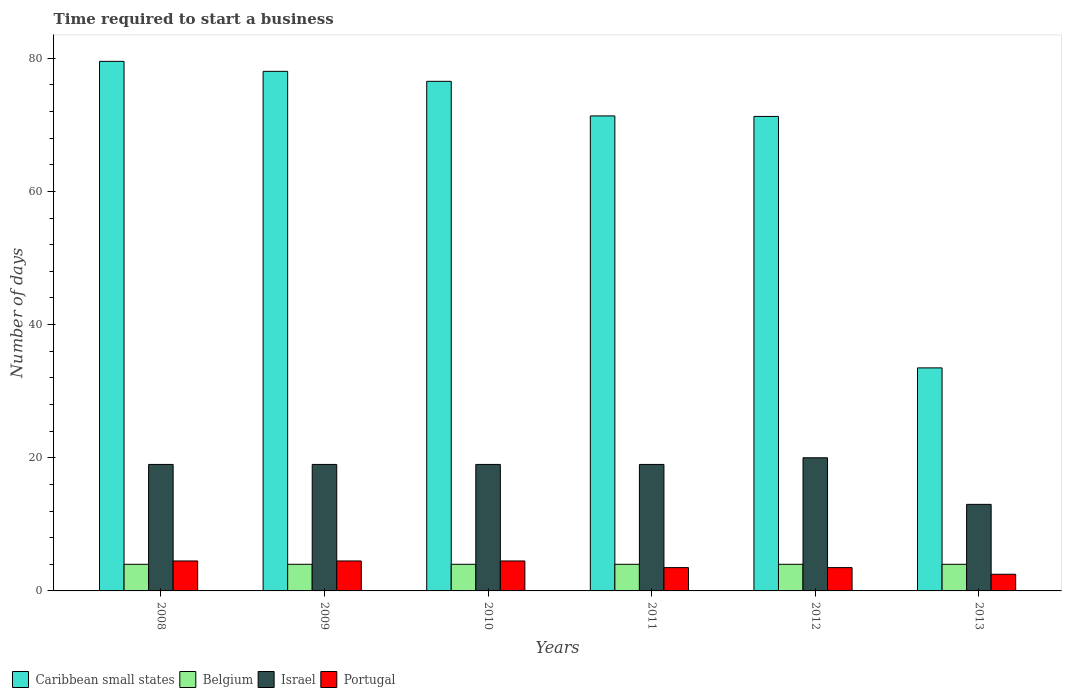How many different coloured bars are there?
Your answer should be very brief. 4. How many groups of bars are there?
Your answer should be very brief. 6. Are the number of bars per tick equal to the number of legend labels?
Your response must be concise. Yes. Are the number of bars on each tick of the X-axis equal?
Provide a succinct answer. Yes. How many bars are there on the 1st tick from the right?
Offer a very short reply. 4. What is the label of the 2nd group of bars from the left?
Your answer should be compact. 2009. Across all years, what is the maximum number of days required to start a business in Israel?
Your answer should be very brief. 20. Across all years, what is the minimum number of days required to start a business in Portugal?
Your response must be concise. 2.5. In which year was the number of days required to start a business in Portugal minimum?
Provide a succinct answer. 2013. What is the total number of days required to start a business in Caribbean small states in the graph?
Offer a terse response. 410.24. What is the difference between the number of days required to start a business in Belgium in 2009 and that in 2011?
Offer a terse response. 0. What is the difference between the number of days required to start a business in Caribbean small states in 2008 and the number of days required to start a business in Portugal in 2010?
Your answer should be very brief. 75.04. What is the average number of days required to start a business in Israel per year?
Your answer should be very brief. 18.17. What is the ratio of the number of days required to start a business in Caribbean small states in 2010 to that in 2013?
Give a very brief answer. 2.28. Is the number of days required to start a business in Israel in 2010 less than that in 2013?
Offer a very short reply. No. What is the difference between the highest and the lowest number of days required to start a business in Belgium?
Provide a short and direct response. 0. Is it the case that in every year, the sum of the number of days required to start a business in Israel and number of days required to start a business in Belgium is greater than the sum of number of days required to start a business in Portugal and number of days required to start a business in Caribbean small states?
Provide a short and direct response. Yes. What does the 1st bar from the left in 2008 represents?
Ensure brevity in your answer.  Caribbean small states. How many bars are there?
Your answer should be compact. 24. Are all the bars in the graph horizontal?
Ensure brevity in your answer.  No. How many years are there in the graph?
Your answer should be very brief. 6. What is the difference between two consecutive major ticks on the Y-axis?
Keep it short and to the point. 20. How are the legend labels stacked?
Your answer should be very brief. Horizontal. What is the title of the graph?
Offer a terse response. Time required to start a business. Does "Sweden" appear as one of the legend labels in the graph?
Your answer should be compact. No. What is the label or title of the Y-axis?
Provide a succinct answer. Number of days. What is the Number of days of Caribbean small states in 2008?
Keep it short and to the point. 79.54. What is the Number of days of Portugal in 2008?
Your answer should be compact. 4.5. What is the Number of days of Caribbean small states in 2009?
Your response must be concise. 78.04. What is the Number of days of Belgium in 2009?
Your response must be concise. 4. What is the Number of days of Caribbean small states in 2010?
Offer a terse response. 76.54. What is the Number of days in Israel in 2010?
Offer a very short reply. 19. What is the Number of days of Caribbean small states in 2011?
Give a very brief answer. 71.35. What is the Number of days of Belgium in 2011?
Make the answer very short. 4. What is the Number of days in Israel in 2011?
Your answer should be very brief. 19. What is the Number of days in Caribbean small states in 2012?
Offer a very short reply. 71.27. What is the Number of days in Portugal in 2012?
Keep it short and to the point. 3.5. What is the Number of days of Caribbean small states in 2013?
Offer a terse response. 33.5. What is the Number of days in Israel in 2013?
Your answer should be compact. 13. Across all years, what is the maximum Number of days in Caribbean small states?
Provide a short and direct response. 79.54. Across all years, what is the maximum Number of days of Portugal?
Offer a very short reply. 4.5. Across all years, what is the minimum Number of days in Caribbean small states?
Offer a very short reply. 33.5. Across all years, what is the minimum Number of days in Portugal?
Provide a succinct answer. 2.5. What is the total Number of days of Caribbean small states in the graph?
Your response must be concise. 410.24. What is the total Number of days of Belgium in the graph?
Your answer should be compact. 24. What is the total Number of days in Israel in the graph?
Offer a very short reply. 109. What is the difference between the Number of days in Caribbean small states in 2008 and that in 2009?
Provide a short and direct response. 1.5. What is the difference between the Number of days of Caribbean small states in 2008 and that in 2010?
Ensure brevity in your answer.  3. What is the difference between the Number of days of Belgium in 2008 and that in 2010?
Ensure brevity in your answer.  0. What is the difference between the Number of days of Portugal in 2008 and that in 2010?
Your response must be concise. 0. What is the difference between the Number of days of Caribbean small states in 2008 and that in 2011?
Your answer should be compact. 8.2. What is the difference between the Number of days of Belgium in 2008 and that in 2011?
Your answer should be very brief. 0. What is the difference between the Number of days of Caribbean small states in 2008 and that in 2012?
Ensure brevity in your answer.  8.27. What is the difference between the Number of days in Belgium in 2008 and that in 2012?
Ensure brevity in your answer.  0. What is the difference between the Number of days of Portugal in 2008 and that in 2012?
Your answer should be compact. 1. What is the difference between the Number of days of Caribbean small states in 2008 and that in 2013?
Your response must be concise. 46.04. What is the difference between the Number of days in Israel in 2008 and that in 2013?
Ensure brevity in your answer.  6. What is the difference between the Number of days of Belgium in 2009 and that in 2010?
Provide a succinct answer. 0. What is the difference between the Number of days in Israel in 2009 and that in 2010?
Offer a terse response. 0. What is the difference between the Number of days in Portugal in 2009 and that in 2010?
Offer a terse response. 0. What is the difference between the Number of days of Caribbean small states in 2009 and that in 2011?
Your answer should be compact. 6.7. What is the difference between the Number of days in Belgium in 2009 and that in 2011?
Provide a short and direct response. 0. What is the difference between the Number of days of Portugal in 2009 and that in 2011?
Your response must be concise. 1. What is the difference between the Number of days of Caribbean small states in 2009 and that in 2012?
Offer a very short reply. 6.77. What is the difference between the Number of days of Portugal in 2009 and that in 2012?
Offer a very short reply. 1. What is the difference between the Number of days in Caribbean small states in 2009 and that in 2013?
Make the answer very short. 44.54. What is the difference between the Number of days in Israel in 2009 and that in 2013?
Ensure brevity in your answer.  6. What is the difference between the Number of days of Caribbean small states in 2010 and that in 2011?
Your answer should be very brief. 5.2. What is the difference between the Number of days of Caribbean small states in 2010 and that in 2012?
Provide a short and direct response. 5.27. What is the difference between the Number of days of Belgium in 2010 and that in 2012?
Ensure brevity in your answer.  0. What is the difference between the Number of days of Israel in 2010 and that in 2012?
Give a very brief answer. -1. What is the difference between the Number of days of Caribbean small states in 2010 and that in 2013?
Provide a short and direct response. 43.04. What is the difference between the Number of days of Portugal in 2010 and that in 2013?
Offer a terse response. 2. What is the difference between the Number of days of Caribbean small states in 2011 and that in 2012?
Your answer should be compact. 0.08. What is the difference between the Number of days in Belgium in 2011 and that in 2012?
Make the answer very short. 0. What is the difference between the Number of days of Israel in 2011 and that in 2012?
Your answer should be very brief. -1. What is the difference between the Number of days in Caribbean small states in 2011 and that in 2013?
Make the answer very short. 37.85. What is the difference between the Number of days in Belgium in 2011 and that in 2013?
Give a very brief answer. 0. What is the difference between the Number of days in Caribbean small states in 2012 and that in 2013?
Ensure brevity in your answer.  37.77. What is the difference between the Number of days of Belgium in 2012 and that in 2013?
Your answer should be compact. 0. What is the difference between the Number of days in Portugal in 2012 and that in 2013?
Your answer should be very brief. 1. What is the difference between the Number of days in Caribbean small states in 2008 and the Number of days in Belgium in 2009?
Offer a terse response. 75.54. What is the difference between the Number of days of Caribbean small states in 2008 and the Number of days of Israel in 2009?
Your answer should be compact. 60.54. What is the difference between the Number of days in Caribbean small states in 2008 and the Number of days in Portugal in 2009?
Your answer should be very brief. 75.04. What is the difference between the Number of days in Belgium in 2008 and the Number of days in Israel in 2009?
Provide a succinct answer. -15. What is the difference between the Number of days in Belgium in 2008 and the Number of days in Portugal in 2009?
Offer a very short reply. -0.5. What is the difference between the Number of days in Caribbean small states in 2008 and the Number of days in Belgium in 2010?
Give a very brief answer. 75.54. What is the difference between the Number of days of Caribbean small states in 2008 and the Number of days of Israel in 2010?
Provide a short and direct response. 60.54. What is the difference between the Number of days in Caribbean small states in 2008 and the Number of days in Portugal in 2010?
Your response must be concise. 75.04. What is the difference between the Number of days in Belgium in 2008 and the Number of days in Israel in 2010?
Provide a short and direct response. -15. What is the difference between the Number of days in Belgium in 2008 and the Number of days in Portugal in 2010?
Make the answer very short. -0.5. What is the difference between the Number of days of Caribbean small states in 2008 and the Number of days of Belgium in 2011?
Your answer should be very brief. 75.54. What is the difference between the Number of days of Caribbean small states in 2008 and the Number of days of Israel in 2011?
Your answer should be very brief. 60.54. What is the difference between the Number of days in Caribbean small states in 2008 and the Number of days in Portugal in 2011?
Your response must be concise. 76.04. What is the difference between the Number of days of Belgium in 2008 and the Number of days of Israel in 2011?
Provide a short and direct response. -15. What is the difference between the Number of days of Belgium in 2008 and the Number of days of Portugal in 2011?
Your response must be concise. 0.5. What is the difference between the Number of days of Caribbean small states in 2008 and the Number of days of Belgium in 2012?
Make the answer very short. 75.54. What is the difference between the Number of days of Caribbean small states in 2008 and the Number of days of Israel in 2012?
Your answer should be compact. 59.54. What is the difference between the Number of days in Caribbean small states in 2008 and the Number of days in Portugal in 2012?
Make the answer very short. 76.04. What is the difference between the Number of days in Belgium in 2008 and the Number of days in Israel in 2012?
Your answer should be compact. -16. What is the difference between the Number of days in Caribbean small states in 2008 and the Number of days in Belgium in 2013?
Offer a very short reply. 75.54. What is the difference between the Number of days of Caribbean small states in 2008 and the Number of days of Israel in 2013?
Offer a terse response. 66.54. What is the difference between the Number of days of Caribbean small states in 2008 and the Number of days of Portugal in 2013?
Provide a succinct answer. 77.04. What is the difference between the Number of days in Belgium in 2008 and the Number of days in Portugal in 2013?
Provide a short and direct response. 1.5. What is the difference between the Number of days of Israel in 2008 and the Number of days of Portugal in 2013?
Provide a short and direct response. 16.5. What is the difference between the Number of days in Caribbean small states in 2009 and the Number of days in Belgium in 2010?
Ensure brevity in your answer.  74.04. What is the difference between the Number of days of Caribbean small states in 2009 and the Number of days of Israel in 2010?
Your answer should be very brief. 59.04. What is the difference between the Number of days of Caribbean small states in 2009 and the Number of days of Portugal in 2010?
Ensure brevity in your answer.  73.54. What is the difference between the Number of days in Caribbean small states in 2009 and the Number of days in Belgium in 2011?
Offer a terse response. 74.04. What is the difference between the Number of days of Caribbean small states in 2009 and the Number of days of Israel in 2011?
Give a very brief answer. 59.04. What is the difference between the Number of days in Caribbean small states in 2009 and the Number of days in Portugal in 2011?
Provide a short and direct response. 74.54. What is the difference between the Number of days of Caribbean small states in 2009 and the Number of days of Belgium in 2012?
Offer a very short reply. 74.04. What is the difference between the Number of days in Caribbean small states in 2009 and the Number of days in Israel in 2012?
Your answer should be compact. 58.04. What is the difference between the Number of days in Caribbean small states in 2009 and the Number of days in Portugal in 2012?
Provide a short and direct response. 74.54. What is the difference between the Number of days of Belgium in 2009 and the Number of days of Portugal in 2012?
Offer a very short reply. 0.5. What is the difference between the Number of days in Caribbean small states in 2009 and the Number of days in Belgium in 2013?
Your answer should be compact. 74.04. What is the difference between the Number of days of Caribbean small states in 2009 and the Number of days of Israel in 2013?
Your answer should be compact. 65.04. What is the difference between the Number of days of Caribbean small states in 2009 and the Number of days of Portugal in 2013?
Provide a short and direct response. 75.54. What is the difference between the Number of days of Belgium in 2009 and the Number of days of Israel in 2013?
Your answer should be compact. -9. What is the difference between the Number of days in Caribbean small states in 2010 and the Number of days in Belgium in 2011?
Give a very brief answer. 72.54. What is the difference between the Number of days of Caribbean small states in 2010 and the Number of days of Israel in 2011?
Offer a terse response. 57.54. What is the difference between the Number of days in Caribbean small states in 2010 and the Number of days in Portugal in 2011?
Offer a terse response. 73.04. What is the difference between the Number of days in Belgium in 2010 and the Number of days in Israel in 2011?
Offer a terse response. -15. What is the difference between the Number of days of Caribbean small states in 2010 and the Number of days of Belgium in 2012?
Offer a terse response. 72.54. What is the difference between the Number of days of Caribbean small states in 2010 and the Number of days of Israel in 2012?
Your response must be concise. 56.54. What is the difference between the Number of days of Caribbean small states in 2010 and the Number of days of Portugal in 2012?
Your answer should be very brief. 73.04. What is the difference between the Number of days of Belgium in 2010 and the Number of days of Portugal in 2012?
Keep it short and to the point. 0.5. What is the difference between the Number of days of Caribbean small states in 2010 and the Number of days of Belgium in 2013?
Provide a short and direct response. 72.54. What is the difference between the Number of days in Caribbean small states in 2010 and the Number of days in Israel in 2013?
Ensure brevity in your answer.  63.54. What is the difference between the Number of days of Caribbean small states in 2010 and the Number of days of Portugal in 2013?
Keep it short and to the point. 74.04. What is the difference between the Number of days of Belgium in 2010 and the Number of days of Israel in 2013?
Provide a short and direct response. -9. What is the difference between the Number of days of Caribbean small states in 2011 and the Number of days of Belgium in 2012?
Offer a very short reply. 67.35. What is the difference between the Number of days in Caribbean small states in 2011 and the Number of days in Israel in 2012?
Provide a succinct answer. 51.35. What is the difference between the Number of days in Caribbean small states in 2011 and the Number of days in Portugal in 2012?
Keep it short and to the point. 67.85. What is the difference between the Number of days in Belgium in 2011 and the Number of days in Israel in 2012?
Provide a succinct answer. -16. What is the difference between the Number of days in Israel in 2011 and the Number of days in Portugal in 2012?
Offer a very short reply. 15.5. What is the difference between the Number of days in Caribbean small states in 2011 and the Number of days in Belgium in 2013?
Offer a terse response. 67.35. What is the difference between the Number of days in Caribbean small states in 2011 and the Number of days in Israel in 2013?
Your answer should be compact. 58.35. What is the difference between the Number of days in Caribbean small states in 2011 and the Number of days in Portugal in 2013?
Your response must be concise. 68.85. What is the difference between the Number of days of Belgium in 2011 and the Number of days of Israel in 2013?
Ensure brevity in your answer.  -9. What is the difference between the Number of days of Belgium in 2011 and the Number of days of Portugal in 2013?
Offer a very short reply. 1.5. What is the difference between the Number of days in Israel in 2011 and the Number of days in Portugal in 2013?
Give a very brief answer. 16.5. What is the difference between the Number of days of Caribbean small states in 2012 and the Number of days of Belgium in 2013?
Your answer should be very brief. 67.27. What is the difference between the Number of days of Caribbean small states in 2012 and the Number of days of Israel in 2013?
Provide a short and direct response. 58.27. What is the difference between the Number of days of Caribbean small states in 2012 and the Number of days of Portugal in 2013?
Your answer should be compact. 68.77. What is the difference between the Number of days of Belgium in 2012 and the Number of days of Israel in 2013?
Your response must be concise. -9. What is the average Number of days of Caribbean small states per year?
Your answer should be compact. 68.37. What is the average Number of days in Israel per year?
Make the answer very short. 18.17. What is the average Number of days in Portugal per year?
Your answer should be very brief. 3.83. In the year 2008, what is the difference between the Number of days of Caribbean small states and Number of days of Belgium?
Offer a terse response. 75.54. In the year 2008, what is the difference between the Number of days of Caribbean small states and Number of days of Israel?
Provide a succinct answer. 60.54. In the year 2008, what is the difference between the Number of days in Caribbean small states and Number of days in Portugal?
Provide a short and direct response. 75.04. In the year 2008, what is the difference between the Number of days in Belgium and Number of days in Israel?
Ensure brevity in your answer.  -15. In the year 2008, what is the difference between the Number of days in Belgium and Number of days in Portugal?
Your response must be concise. -0.5. In the year 2009, what is the difference between the Number of days in Caribbean small states and Number of days in Belgium?
Provide a succinct answer. 74.04. In the year 2009, what is the difference between the Number of days in Caribbean small states and Number of days in Israel?
Keep it short and to the point. 59.04. In the year 2009, what is the difference between the Number of days of Caribbean small states and Number of days of Portugal?
Your response must be concise. 73.54. In the year 2009, what is the difference between the Number of days of Belgium and Number of days of Portugal?
Make the answer very short. -0.5. In the year 2010, what is the difference between the Number of days of Caribbean small states and Number of days of Belgium?
Your answer should be very brief. 72.54. In the year 2010, what is the difference between the Number of days in Caribbean small states and Number of days in Israel?
Give a very brief answer. 57.54. In the year 2010, what is the difference between the Number of days in Caribbean small states and Number of days in Portugal?
Give a very brief answer. 72.04. In the year 2010, what is the difference between the Number of days of Israel and Number of days of Portugal?
Your answer should be compact. 14.5. In the year 2011, what is the difference between the Number of days in Caribbean small states and Number of days in Belgium?
Ensure brevity in your answer.  67.35. In the year 2011, what is the difference between the Number of days of Caribbean small states and Number of days of Israel?
Your answer should be compact. 52.35. In the year 2011, what is the difference between the Number of days of Caribbean small states and Number of days of Portugal?
Your response must be concise. 67.85. In the year 2011, what is the difference between the Number of days of Belgium and Number of days of Portugal?
Provide a short and direct response. 0.5. In the year 2012, what is the difference between the Number of days in Caribbean small states and Number of days in Belgium?
Keep it short and to the point. 67.27. In the year 2012, what is the difference between the Number of days of Caribbean small states and Number of days of Israel?
Your response must be concise. 51.27. In the year 2012, what is the difference between the Number of days of Caribbean small states and Number of days of Portugal?
Provide a short and direct response. 67.77. In the year 2012, what is the difference between the Number of days in Belgium and Number of days in Israel?
Keep it short and to the point. -16. In the year 2013, what is the difference between the Number of days in Caribbean small states and Number of days in Belgium?
Provide a short and direct response. 29.5. In the year 2013, what is the difference between the Number of days in Caribbean small states and Number of days in Israel?
Make the answer very short. 20.5. In the year 2013, what is the difference between the Number of days in Belgium and Number of days in Israel?
Offer a terse response. -9. In the year 2013, what is the difference between the Number of days in Israel and Number of days in Portugal?
Ensure brevity in your answer.  10.5. What is the ratio of the Number of days of Caribbean small states in 2008 to that in 2009?
Offer a very short reply. 1.02. What is the ratio of the Number of days in Belgium in 2008 to that in 2009?
Provide a succinct answer. 1. What is the ratio of the Number of days in Israel in 2008 to that in 2009?
Offer a terse response. 1. What is the ratio of the Number of days in Caribbean small states in 2008 to that in 2010?
Give a very brief answer. 1.04. What is the ratio of the Number of days of Belgium in 2008 to that in 2010?
Your response must be concise. 1. What is the ratio of the Number of days of Israel in 2008 to that in 2010?
Provide a succinct answer. 1. What is the ratio of the Number of days of Caribbean small states in 2008 to that in 2011?
Your answer should be compact. 1.11. What is the ratio of the Number of days of Israel in 2008 to that in 2011?
Provide a succinct answer. 1. What is the ratio of the Number of days in Portugal in 2008 to that in 2011?
Your answer should be compact. 1.29. What is the ratio of the Number of days in Caribbean small states in 2008 to that in 2012?
Make the answer very short. 1.12. What is the ratio of the Number of days of Belgium in 2008 to that in 2012?
Keep it short and to the point. 1. What is the ratio of the Number of days in Portugal in 2008 to that in 2012?
Offer a very short reply. 1.29. What is the ratio of the Number of days of Caribbean small states in 2008 to that in 2013?
Your answer should be compact. 2.37. What is the ratio of the Number of days of Belgium in 2008 to that in 2013?
Your response must be concise. 1. What is the ratio of the Number of days in Israel in 2008 to that in 2013?
Provide a short and direct response. 1.46. What is the ratio of the Number of days of Portugal in 2008 to that in 2013?
Your answer should be compact. 1.8. What is the ratio of the Number of days in Caribbean small states in 2009 to that in 2010?
Ensure brevity in your answer.  1.02. What is the ratio of the Number of days in Belgium in 2009 to that in 2010?
Offer a terse response. 1. What is the ratio of the Number of days in Caribbean small states in 2009 to that in 2011?
Give a very brief answer. 1.09. What is the ratio of the Number of days in Israel in 2009 to that in 2011?
Ensure brevity in your answer.  1. What is the ratio of the Number of days in Caribbean small states in 2009 to that in 2012?
Your answer should be compact. 1.09. What is the ratio of the Number of days in Belgium in 2009 to that in 2012?
Provide a short and direct response. 1. What is the ratio of the Number of days in Caribbean small states in 2009 to that in 2013?
Provide a succinct answer. 2.33. What is the ratio of the Number of days of Belgium in 2009 to that in 2013?
Your answer should be compact. 1. What is the ratio of the Number of days in Israel in 2009 to that in 2013?
Provide a short and direct response. 1.46. What is the ratio of the Number of days of Caribbean small states in 2010 to that in 2011?
Give a very brief answer. 1.07. What is the ratio of the Number of days in Belgium in 2010 to that in 2011?
Give a very brief answer. 1. What is the ratio of the Number of days of Portugal in 2010 to that in 2011?
Offer a very short reply. 1.29. What is the ratio of the Number of days of Caribbean small states in 2010 to that in 2012?
Keep it short and to the point. 1.07. What is the ratio of the Number of days in Israel in 2010 to that in 2012?
Keep it short and to the point. 0.95. What is the ratio of the Number of days of Portugal in 2010 to that in 2012?
Keep it short and to the point. 1.29. What is the ratio of the Number of days in Caribbean small states in 2010 to that in 2013?
Ensure brevity in your answer.  2.28. What is the ratio of the Number of days in Belgium in 2010 to that in 2013?
Your answer should be compact. 1. What is the ratio of the Number of days of Israel in 2010 to that in 2013?
Offer a very short reply. 1.46. What is the ratio of the Number of days in Portugal in 2011 to that in 2012?
Offer a terse response. 1. What is the ratio of the Number of days in Caribbean small states in 2011 to that in 2013?
Provide a short and direct response. 2.13. What is the ratio of the Number of days in Belgium in 2011 to that in 2013?
Your answer should be compact. 1. What is the ratio of the Number of days of Israel in 2011 to that in 2013?
Your response must be concise. 1.46. What is the ratio of the Number of days of Portugal in 2011 to that in 2013?
Provide a short and direct response. 1.4. What is the ratio of the Number of days of Caribbean small states in 2012 to that in 2013?
Offer a very short reply. 2.13. What is the ratio of the Number of days of Israel in 2012 to that in 2013?
Offer a terse response. 1.54. What is the difference between the highest and the second highest Number of days of Caribbean small states?
Offer a terse response. 1.5. What is the difference between the highest and the lowest Number of days of Caribbean small states?
Provide a succinct answer. 46.04. 